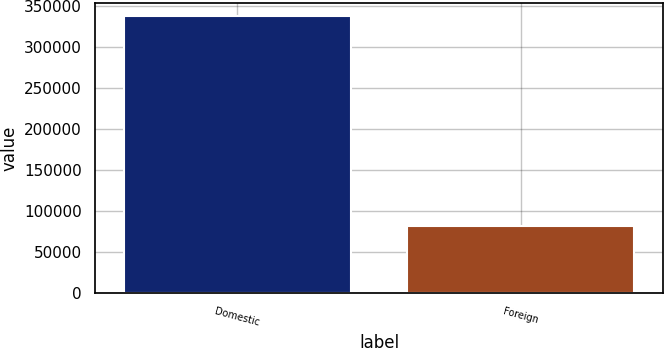<chart> <loc_0><loc_0><loc_500><loc_500><bar_chart><fcel>Domestic<fcel>Foreign<nl><fcel>337402<fcel>81874<nl></chart> 